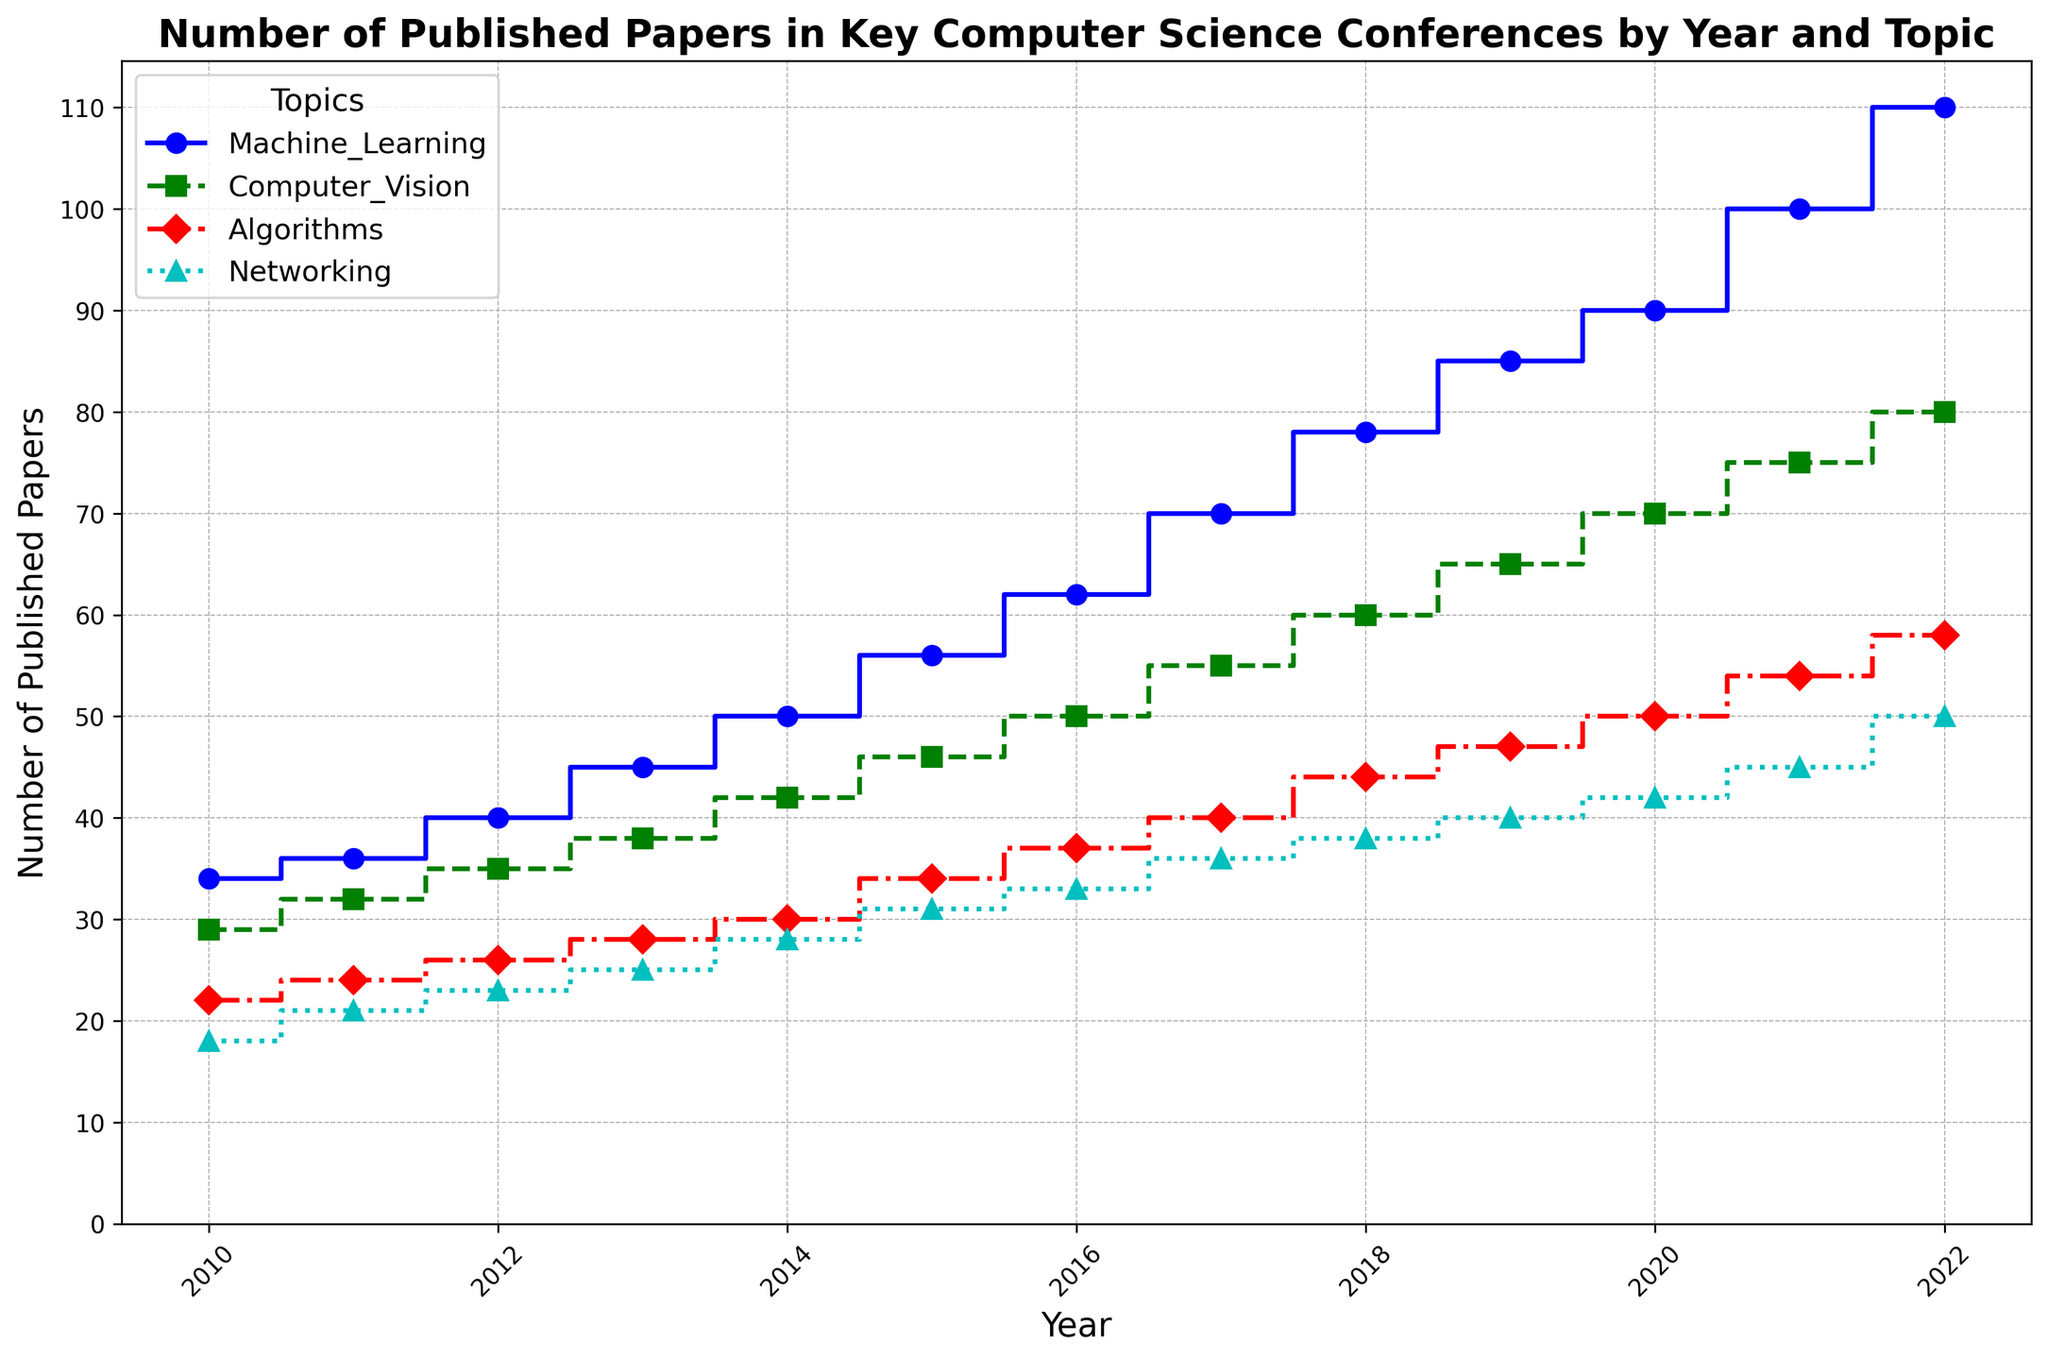What is the overall trend in the number of published papers in the topic of Machine Learning between 2010 and 2022? To determine the trend, observe the heights of the step plot for Machine Learning across the years. We see a consistent increase in the number of published papers from 34 in 2010 to 110 in 2022, indicating a growing interest in this topic.
Answer: Increasing Between which years did the topic of Networking see the largest increase in the number of published papers? To find the largest increase, observe the step heights for Networking. The most significant jump is from 2011 to 2012, where it increases from 21 to 23, and the next notable increase is from 2021 to 2022, with an increase from 45 to 50. The latter period has a larger absolute increase of 5 papers.
Answer: 2021 to 2022 How many more papers were published in Computer Vision than in Algorithms in 2020? Extract the counts for Computer Vision and Algorithms in 2020 from the plot. Computer Vision had 70 papers, while Algorithms had 50 papers. The difference is 70 - 50 = 20.
Answer: 20 Which topic had the smallest number of papers published in 2013? Check the step heights for all topics in 2013. Networking had the smallest number of published papers with 25.
Answer: Networking What is the average number of published papers in the topic of Algorithms over the entire period? Calculate the total number of papers published in Algorithms from 2010 to 2022 and divide by the number of years. The total is 22 + 24 + 26 + 28 + 30 + 34 + 37 + 40 + 44 + 47 + 50 + 54 + 58 = 494, and the average over 13 years is 494 / 13 ≈ 38.
Answer: 38 Compare the growth in the number of published papers for Machine Learning and Computer Vision between 2015 and 2020. Which topic had a higher growth? Machine Learning grew from 56 in 2015 to 90 in 2020, an increase of 34. Computer Vision grew from 46 to 70, an increase of 24. Machine Learning had a higher growth.
Answer: Machine Learning How many total papers were published in Networking from 2016 to 2021? Sum the number of published papers in Networking from 2016 to 2021: 33 (2016) + 36 (2017) + 38 (2018) + 40 (2019) + 42 (2020) + 45 (2021) = 234.
Answer: 234 Which topic had the highest number of published papers in any single year, and what was that number? Identify the highest step among all topics across all years. Machine Learning in 2022 had the highest number with 110 published papers.
Answer: Machine Learning, 110 In what years did the number of published papers in Algorithms exactly equal the number in Networking? Compare the step heights for Algorithms and Networking. In 2010, Algorithms had 22 papers, and Networking had 18, which are not equal. They do not equal each other in any year from 2010 to 2022.
Answer: None 